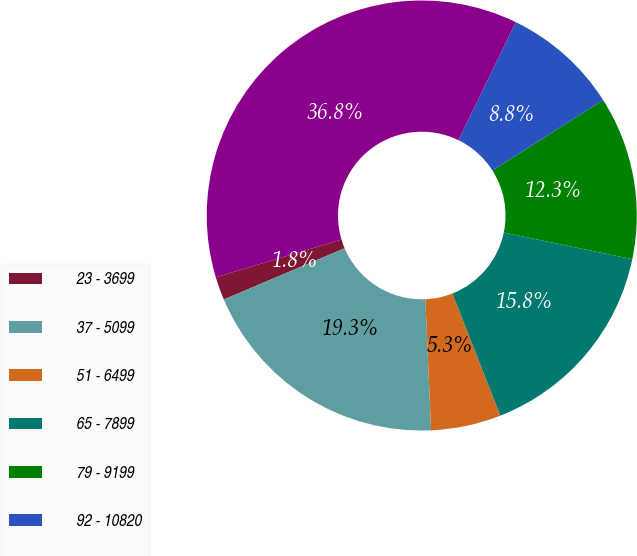<chart> <loc_0><loc_0><loc_500><loc_500><pie_chart><fcel>23 - 3699<fcel>37 - 5099<fcel>51 - 6499<fcel>65 - 7899<fcel>79 - 9199<fcel>92 - 10820<fcel>23 - 10820<nl><fcel>1.75%<fcel>19.3%<fcel>5.26%<fcel>15.79%<fcel>12.28%<fcel>8.77%<fcel>36.84%<nl></chart> 